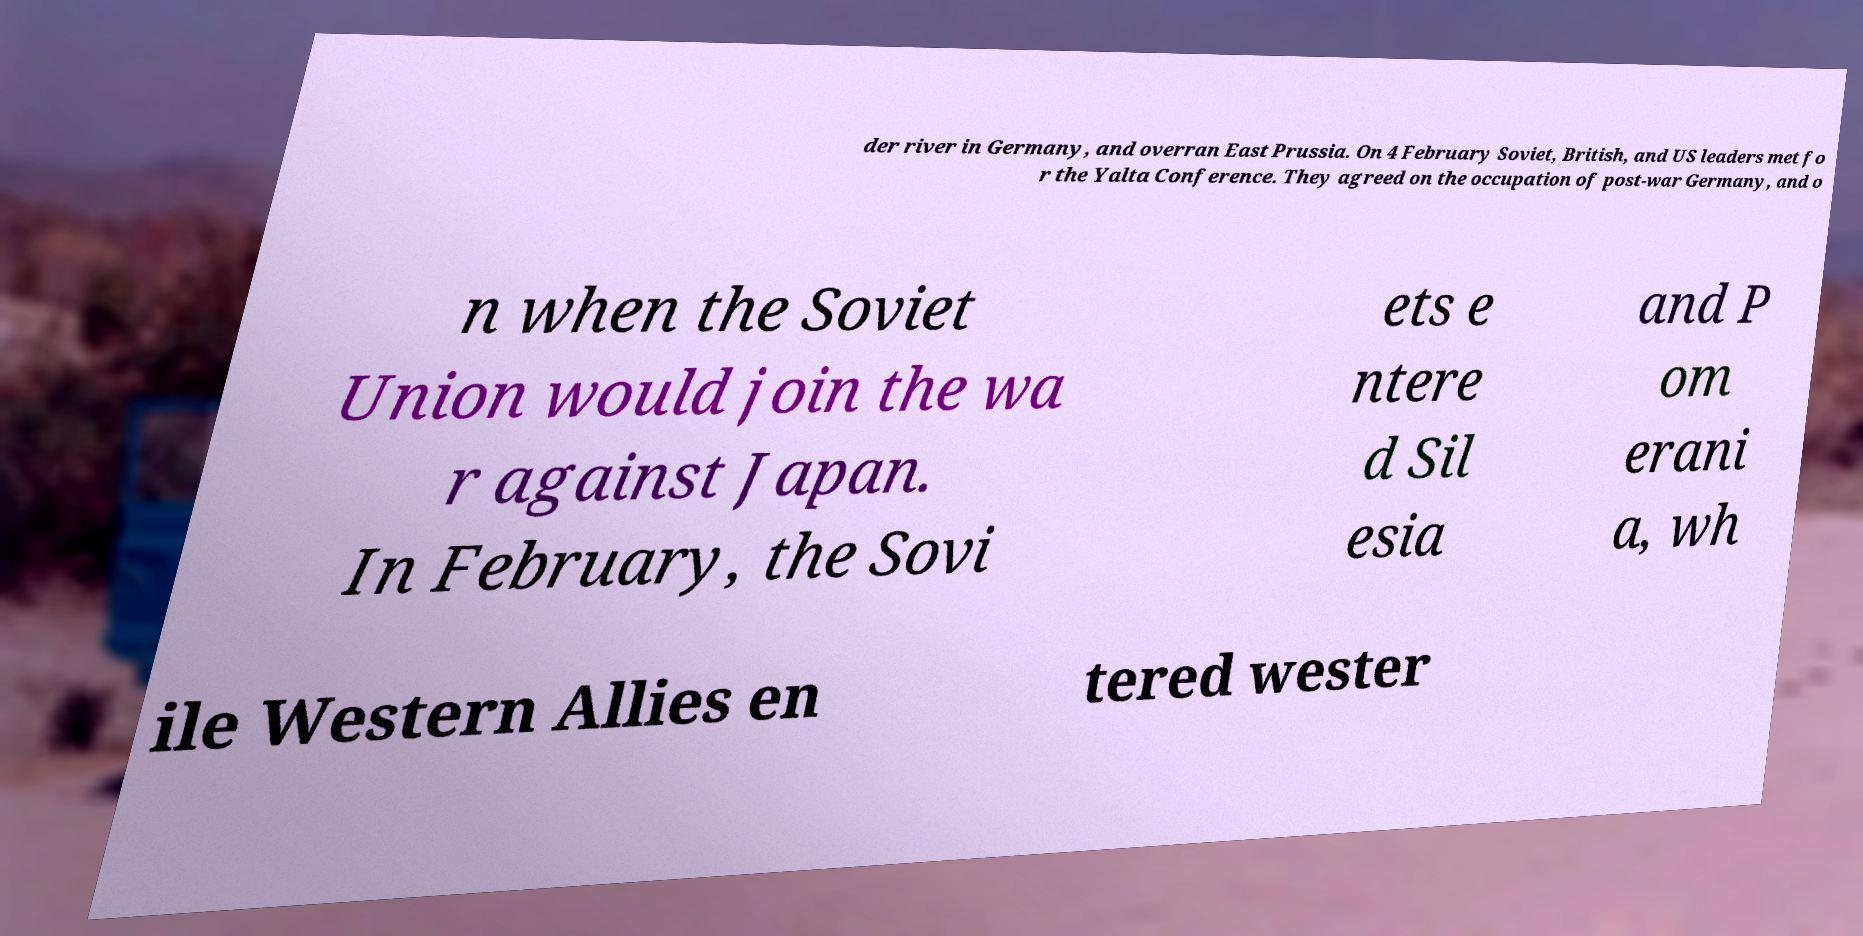There's text embedded in this image that I need extracted. Can you transcribe it verbatim? der river in Germany, and overran East Prussia. On 4 February Soviet, British, and US leaders met fo r the Yalta Conference. They agreed on the occupation of post-war Germany, and o n when the Soviet Union would join the wa r against Japan. In February, the Sovi ets e ntere d Sil esia and P om erani a, wh ile Western Allies en tered wester 